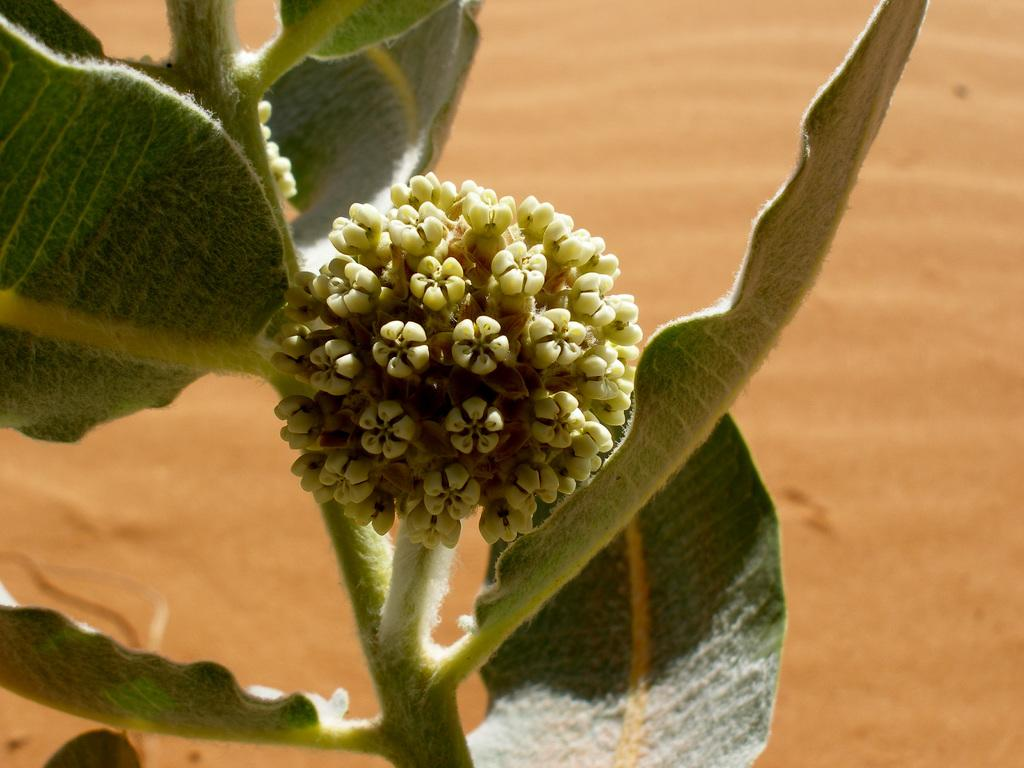What type of plant is visible in the image? There is a plant with a flower in the image. What color is the background of the image? The background of the image is brown. How does the flock of birds interact with the plant in the image? There are no birds present in the image, so a flock of birds cannot interact with the plant. 